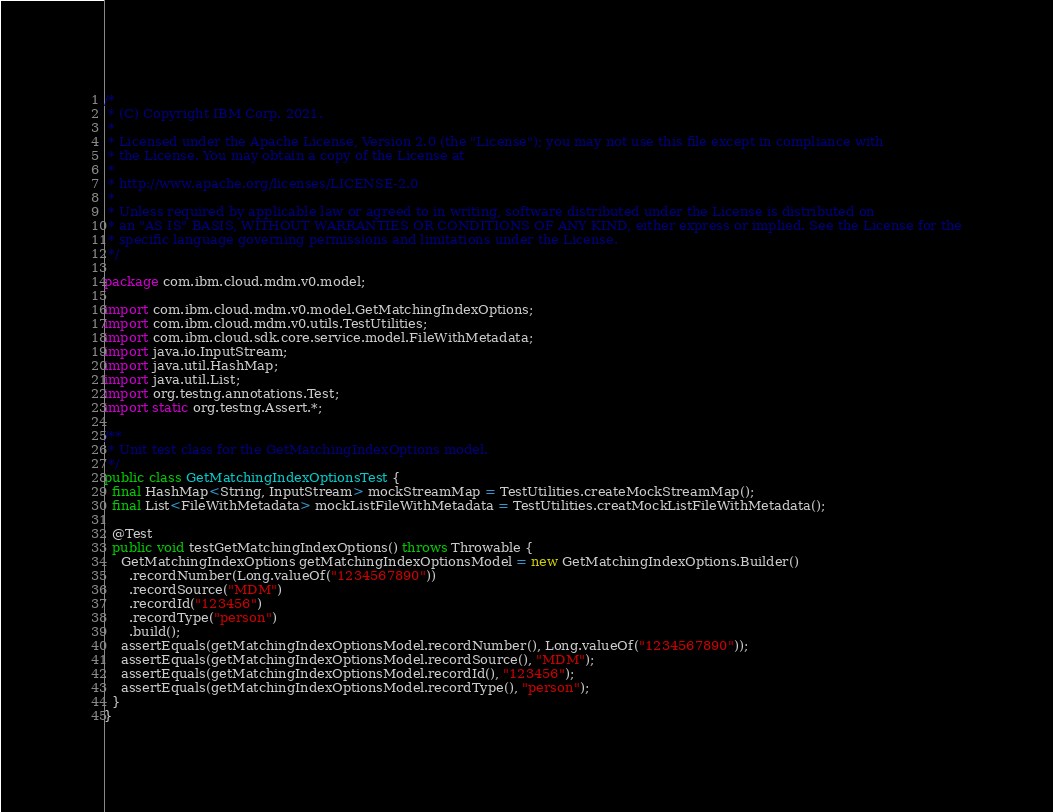Convert code to text. <code><loc_0><loc_0><loc_500><loc_500><_Java_>/*
 * (C) Copyright IBM Corp. 2021.
 *
 * Licensed under the Apache License, Version 2.0 (the "License"); you may not use this file except in compliance with
 * the License. You may obtain a copy of the License at
 *
 * http://www.apache.org/licenses/LICENSE-2.0
 *
 * Unless required by applicable law or agreed to in writing, software distributed under the License is distributed on
 * an "AS IS" BASIS, WITHOUT WARRANTIES OR CONDITIONS OF ANY KIND, either express or implied. See the License for the
 * specific language governing permissions and limitations under the License.
 */

package com.ibm.cloud.mdm.v0.model;

import com.ibm.cloud.mdm.v0.model.GetMatchingIndexOptions;
import com.ibm.cloud.mdm.v0.utils.TestUtilities;
import com.ibm.cloud.sdk.core.service.model.FileWithMetadata;
import java.io.InputStream;
import java.util.HashMap;
import java.util.List;
import org.testng.annotations.Test;
import static org.testng.Assert.*;

/**
 * Unit test class for the GetMatchingIndexOptions model.
 */
public class GetMatchingIndexOptionsTest {
  final HashMap<String, InputStream> mockStreamMap = TestUtilities.createMockStreamMap();
  final List<FileWithMetadata> mockListFileWithMetadata = TestUtilities.creatMockListFileWithMetadata();

  @Test
  public void testGetMatchingIndexOptions() throws Throwable {
    GetMatchingIndexOptions getMatchingIndexOptionsModel = new GetMatchingIndexOptions.Builder()
      .recordNumber(Long.valueOf("1234567890"))
      .recordSource("MDM")
      .recordId("123456")
      .recordType("person")
      .build();
    assertEquals(getMatchingIndexOptionsModel.recordNumber(), Long.valueOf("1234567890"));
    assertEquals(getMatchingIndexOptionsModel.recordSource(), "MDM");
    assertEquals(getMatchingIndexOptionsModel.recordId(), "123456");
    assertEquals(getMatchingIndexOptionsModel.recordType(), "person");
  }
}</code> 